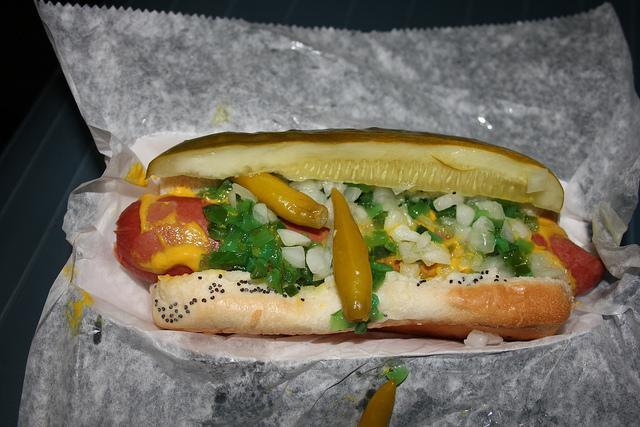How many people are wearing flowers?
Give a very brief answer. 0. 